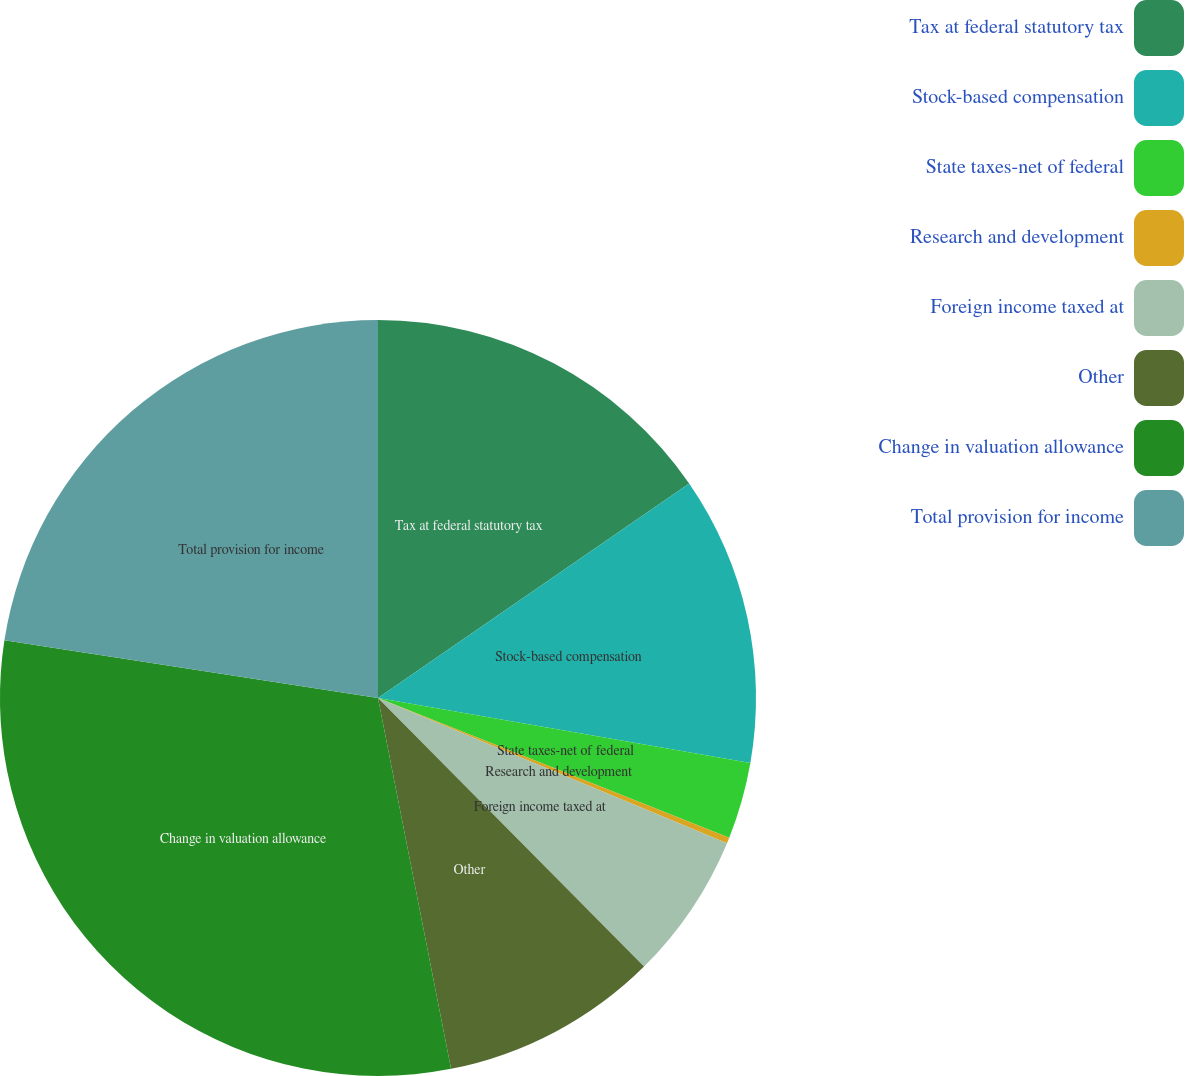Convert chart. <chart><loc_0><loc_0><loc_500><loc_500><pie_chart><fcel>Tax at federal statutory tax<fcel>Stock-based compensation<fcel>State taxes-net of federal<fcel>Research and development<fcel>Foreign income taxed at<fcel>Other<fcel>Change in valuation allowance<fcel>Total provision for income<nl><fcel>15.39%<fcel>12.36%<fcel>3.27%<fcel>0.25%<fcel>6.3%<fcel>9.33%<fcel>30.53%<fcel>22.56%<nl></chart> 